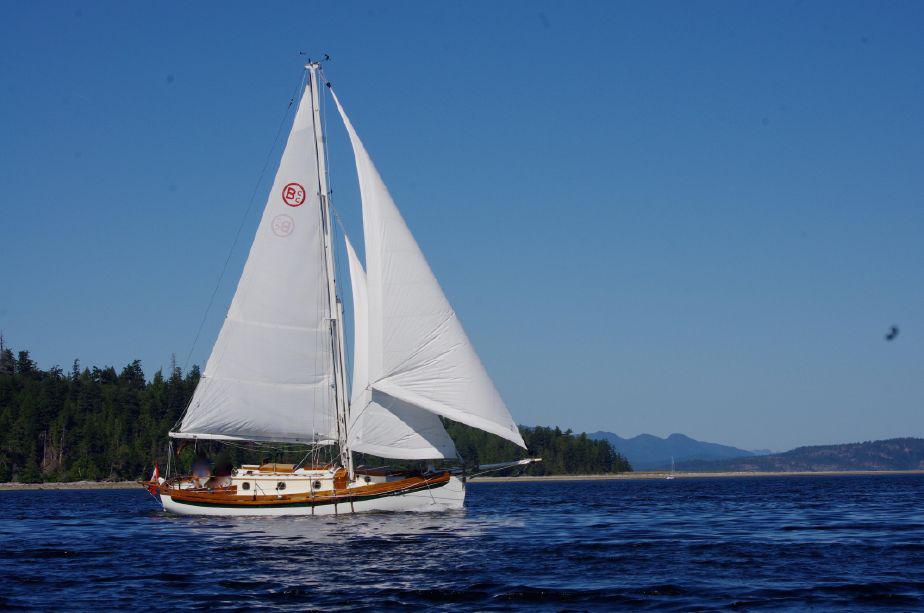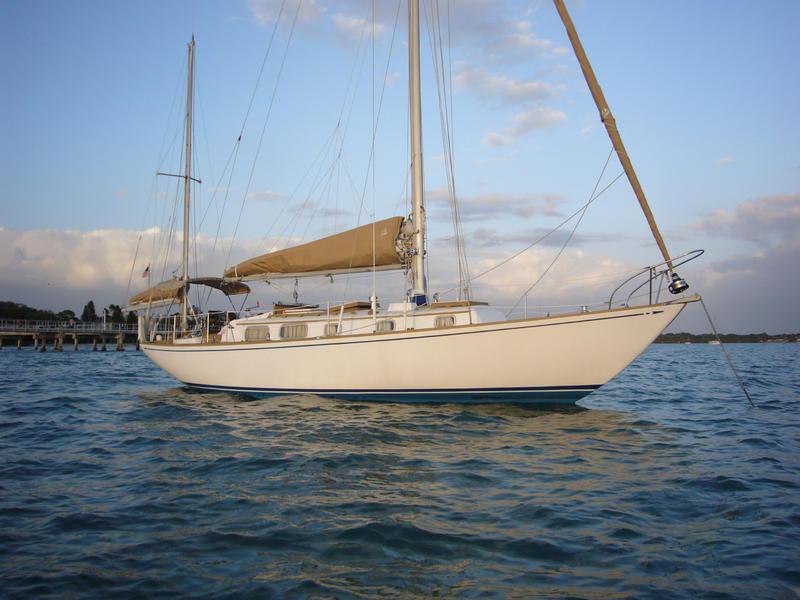The first image is the image on the left, the second image is the image on the right. Evaluate the accuracy of this statement regarding the images: "One of the boats has three opened sails.". Is it true? Answer yes or no. Yes. The first image is the image on the left, the second image is the image on the right. For the images shown, is this caption "The left and right image contains the same number of sailboat sailing on the water in opposite directions." true? Answer yes or no. No. 